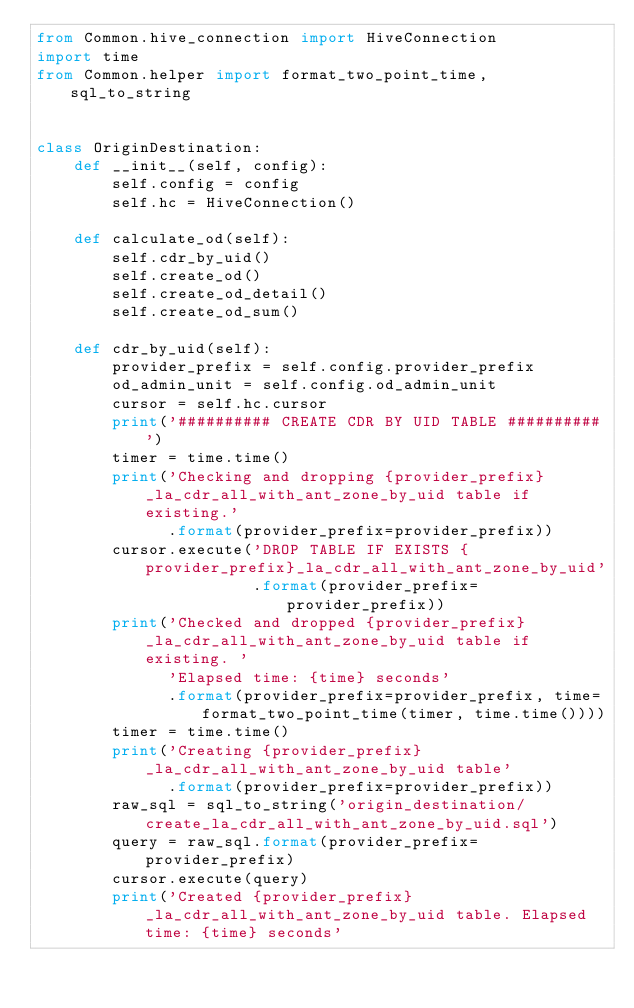<code> <loc_0><loc_0><loc_500><loc_500><_Python_>from Common.hive_connection import HiveConnection
import time
from Common.helper import format_two_point_time, sql_to_string


class OriginDestination:
    def __init__(self, config):
        self.config = config
        self.hc = HiveConnection()

    def calculate_od(self):
        self.cdr_by_uid()
        self.create_od()
        self.create_od_detail()
        self.create_od_sum()

    def cdr_by_uid(self):
        provider_prefix = self.config.provider_prefix
        od_admin_unit = self.config.od_admin_unit
        cursor = self.hc.cursor
        print('########## CREATE CDR BY UID TABLE ##########')
        timer = time.time()
        print('Checking and dropping {provider_prefix}_la_cdr_all_with_ant_zone_by_uid table if existing.'
              .format(provider_prefix=provider_prefix))
        cursor.execute('DROP TABLE IF EXISTS {provider_prefix}_la_cdr_all_with_ant_zone_by_uid'
                       .format(provider_prefix=provider_prefix))
        print('Checked and dropped {provider_prefix}_la_cdr_all_with_ant_zone_by_uid table if existing. '
              'Elapsed time: {time} seconds'
              .format(provider_prefix=provider_prefix, time=format_two_point_time(timer, time.time())))
        timer = time.time()
        print('Creating {provider_prefix}_la_cdr_all_with_ant_zone_by_uid table'
              .format(provider_prefix=provider_prefix))
        raw_sql = sql_to_string('origin_destination/create_la_cdr_all_with_ant_zone_by_uid.sql')
        query = raw_sql.format(provider_prefix=provider_prefix)
        cursor.execute(query)
        print('Created {provider_prefix}_la_cdr_all_with_ant_zone_by_uid table. Elapsed time: {time} seconds'</code> 